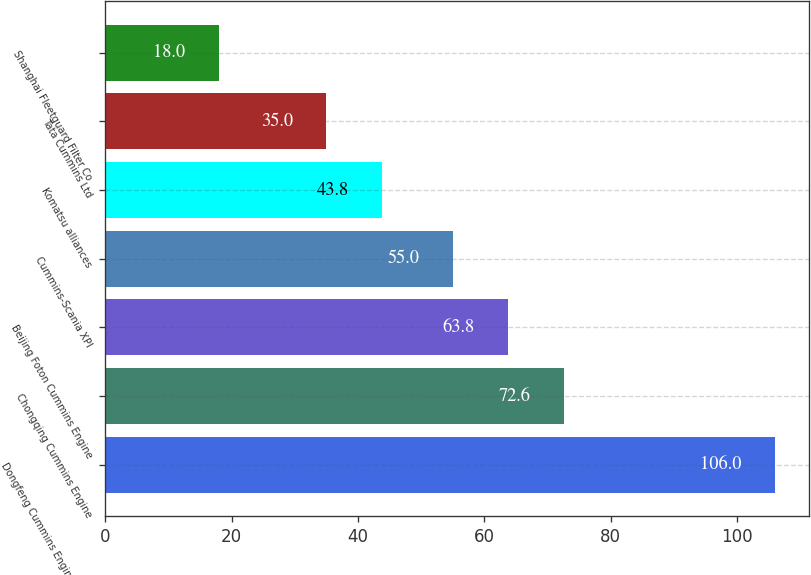<chart> <loc_0><loc_0><loc_500><loc_500><bar_chart><fcel>Dongfeng Cummins Engine Co Ltd<fcel>Chongqing Cummins Engine<fcel>Beijing Foton Cummins Engine<fcel>Cummins-Scania XPI<fcel>Komatsu alliances<fcel>Tata Cummins Ltd<fcel>Shanghai Fleetguard Filter Co<nl><fcel>106<fcel>72.6<fcel>63.8<fcel>55<fcel>43.8<fcel>35<fcel>18<nl></chart> 